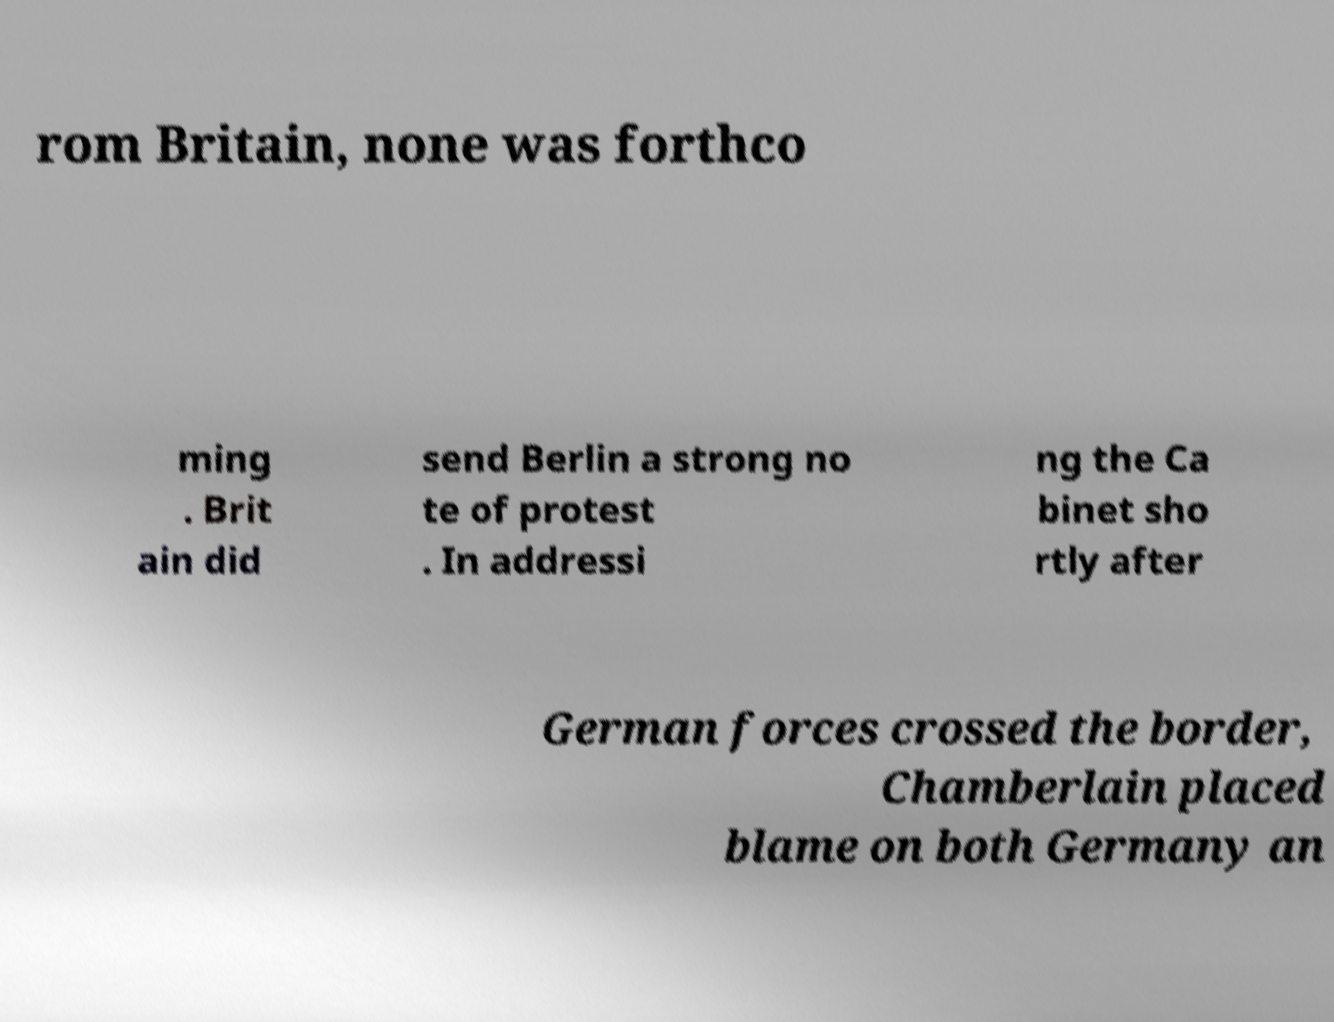Can you read and provide the text displayed in the image?This photo seems to have some interesting text. Can you extract and type it out for me? rom Britain, none was forthco ming . Brit ain did send Berlin a strong no te of protest . In addressi ng the Ca binet sho rtly after German forces crossed the border, Chamberlain placed blame on both Germany an 